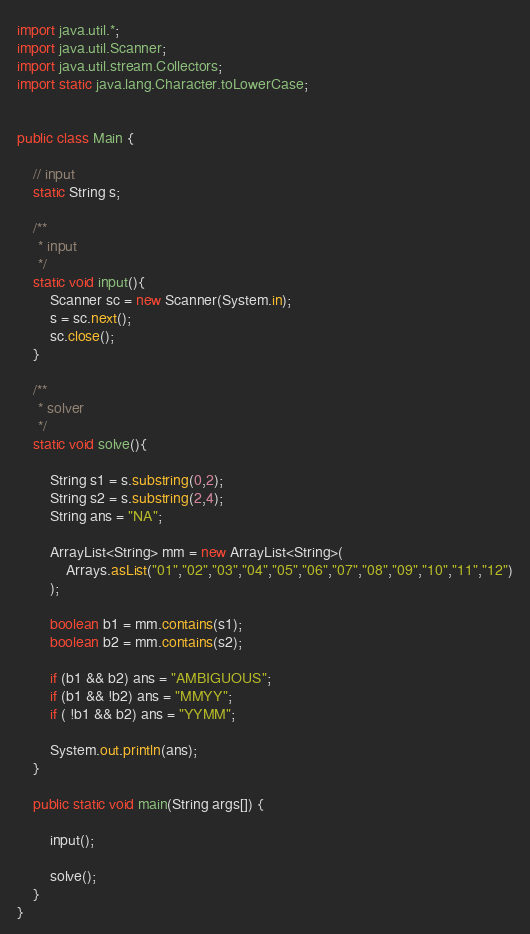<code> <loc_0><loc_0><loc_500><loc_500><_Java_>import java.util.*;
import java.util.Scanner;
import java.util.stream.Collectors;
import static java.lang.Character.toLowerCase;


public class Main {

    // input
    static String s;
    
    /**
     * input
     */
    static void input(){
        Scanner sc = new Scanner(System.in);
        s = sc.next();
        sc.close();
    }
 
    /**
     * solver
     */
    static void solve(){

        String s1 = s.substring(0,2);
        String s2 = s.substring(2,4);
        String ans = "NA";

        ArrayList<String> mm = new ArrayList<String>(
            Arrays.asList("01","02","03","04","05","06","07","08","09","10","11","12")
        );

        boolean b1 = mm.contains(s1);
        boolean b2 = mm.contains(s2);

        if (b1 && b2) ans = "AMBIGUOUS";
        if (b1 && !b2) ans = "MMYY";
        if ( !b1 && b2) ans = "YYMM";

        System.out.println(ans);
    }

    public static void main(String args[]) {

        input();

        solve();
    }
}
</code> 